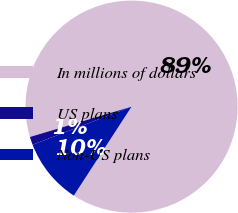Convert chart to OTSL. <chart><loc_0><loc_0><loc_500><loc_500><pie_chart><fcel>In millions of dollars<fcel>US plans<fcel>Non-US plans<nl><fcel>88.78%<fcel>1.23%<fcel>9.99%<nl></chart> 